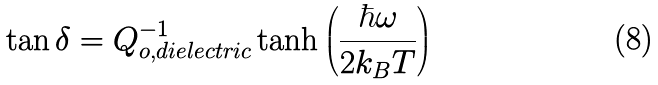Convert formula to latex. <formula><loc_0><loc_0><loc_500><loc_500>\tan \delta = Q ^ { - 1 } _ { o , d i e l e c t r i c } \tanh \left ( \frac { \hbar { \omega } } { 2 k _ { B } T } \right )</formula> 